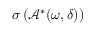Convert formula to latex. <formula><loc_0><loc_0><loc_500><loc_500>\sigma \left ( \mathcal { A } ^ { * } ( \omega , \delta ) \right )</formula> 